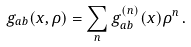<formula> <loc_0><loc_0><loc_500><loc_500>g _ { a b } ( x , \rho ) = \sum _ { n } g _ { a b } ^ { ( n ) } ( x ) \rho ^ { n } \, .</formula> 